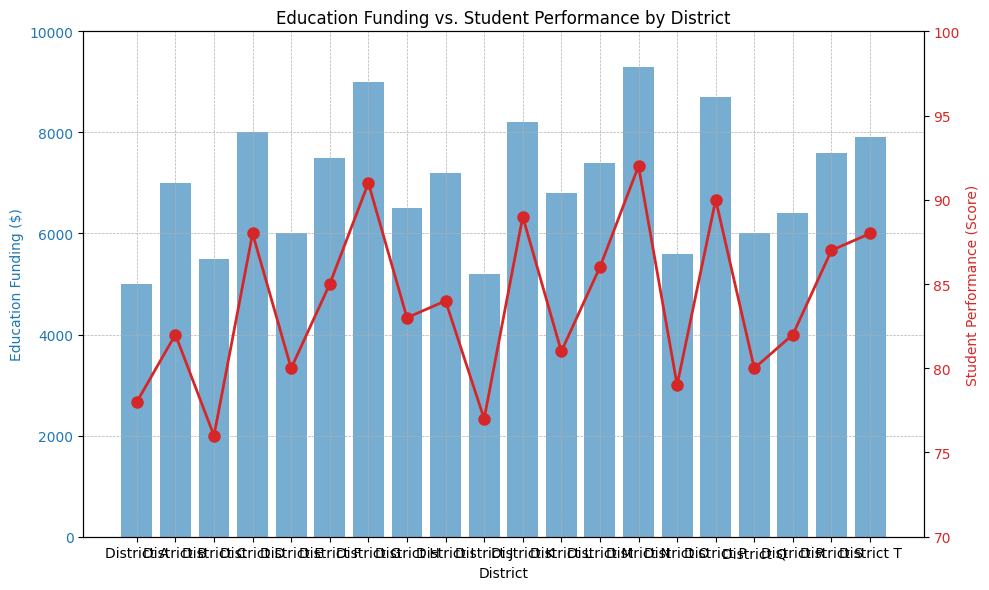What's the highest Education Funding displayed in the figure? The highest Education Funding is indicated by the tallest blue bar in the chart. By inspecting the graph, the tallest blue bar represents District N with $9300.
Answer: $9300 Which district shows the lowest Student Performance score? The lowest Student Performance score corresponds to the lowest red line marker (dot) in the chart. By inspecting the graph, the lowest red dot is at District C with a score of 76.
Answer: District C Which district has both high Education Funding and high Student Performance? Districts with both high Education Funding and high Student Performance would show up as tall blue bars and red dots near the top. By examining the figure, Districts N and P both stand out with high blue bars ($9300 and $8700) and high red dots (92 and 90).
Answer: Districts N and P What is the total Education Funding for Districts D, G, and K? Add the Education Funding for District D ($8000), District G ($9000), and District K ($8200). $8000 + $9000 + $8200 = $25200
Answer: $25200 What is the average Student Performance score across all districts? To find the average, add all the Student Performance scores and divide by the number of districts. Sum: 78+82+76+88+80+85+91+83+84+77+89+81+86+92+79+90+80+82+87+88 = 1618. Number of districts = 20. Average = 1618/20 = 80.9
Answer: 80.9 